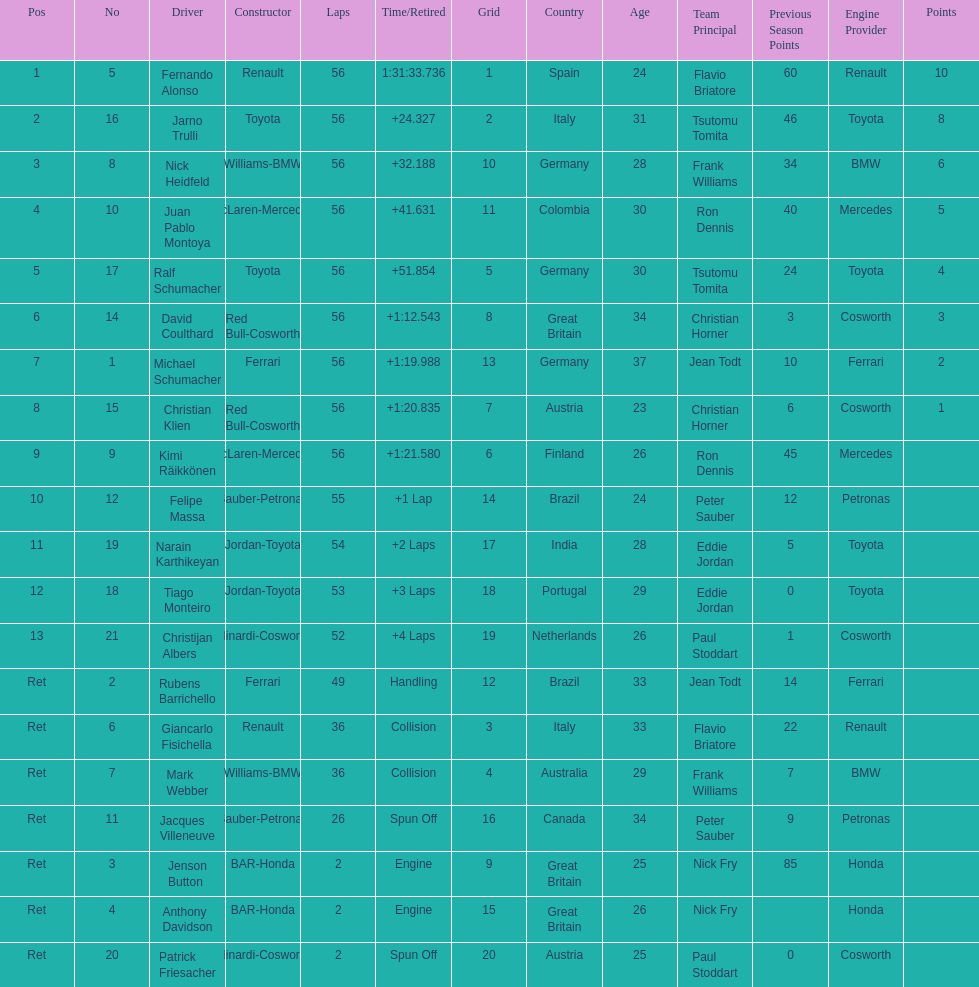Who raced during the 2005 malaysian grand prix? Fernando Alonso, Jarno Trulli, Nick Heidfeld, Juan Pablo Montoya, Ralf Schumacher, David Coulthard, Michael Schumacher, Christian Klien, Kimi Räikkönen, Felipe Massa, Narain Karthikeyan, Tiago Monteiro, Christijan Albers, Rubens Barrichello, Giancarlo Fisichella, Mark Webber, Jacques Villeneuve, Jenson Button, Anthony Davidson, Patrick Friesacher. What were their finishing times? 1:31:33.736, +24.327, +32.188, +41.631, +51.854, +1:12.543, +1:19.988, +1:20.835, +1:21.580, +1 Lap, +2 Laps, +3 Laps, +4 Laps, Handling, Collision, Collision, Spun Off, Engine, Engine, Spun Off. What was fernando alonso's finishing time? 1:31:33.736. 